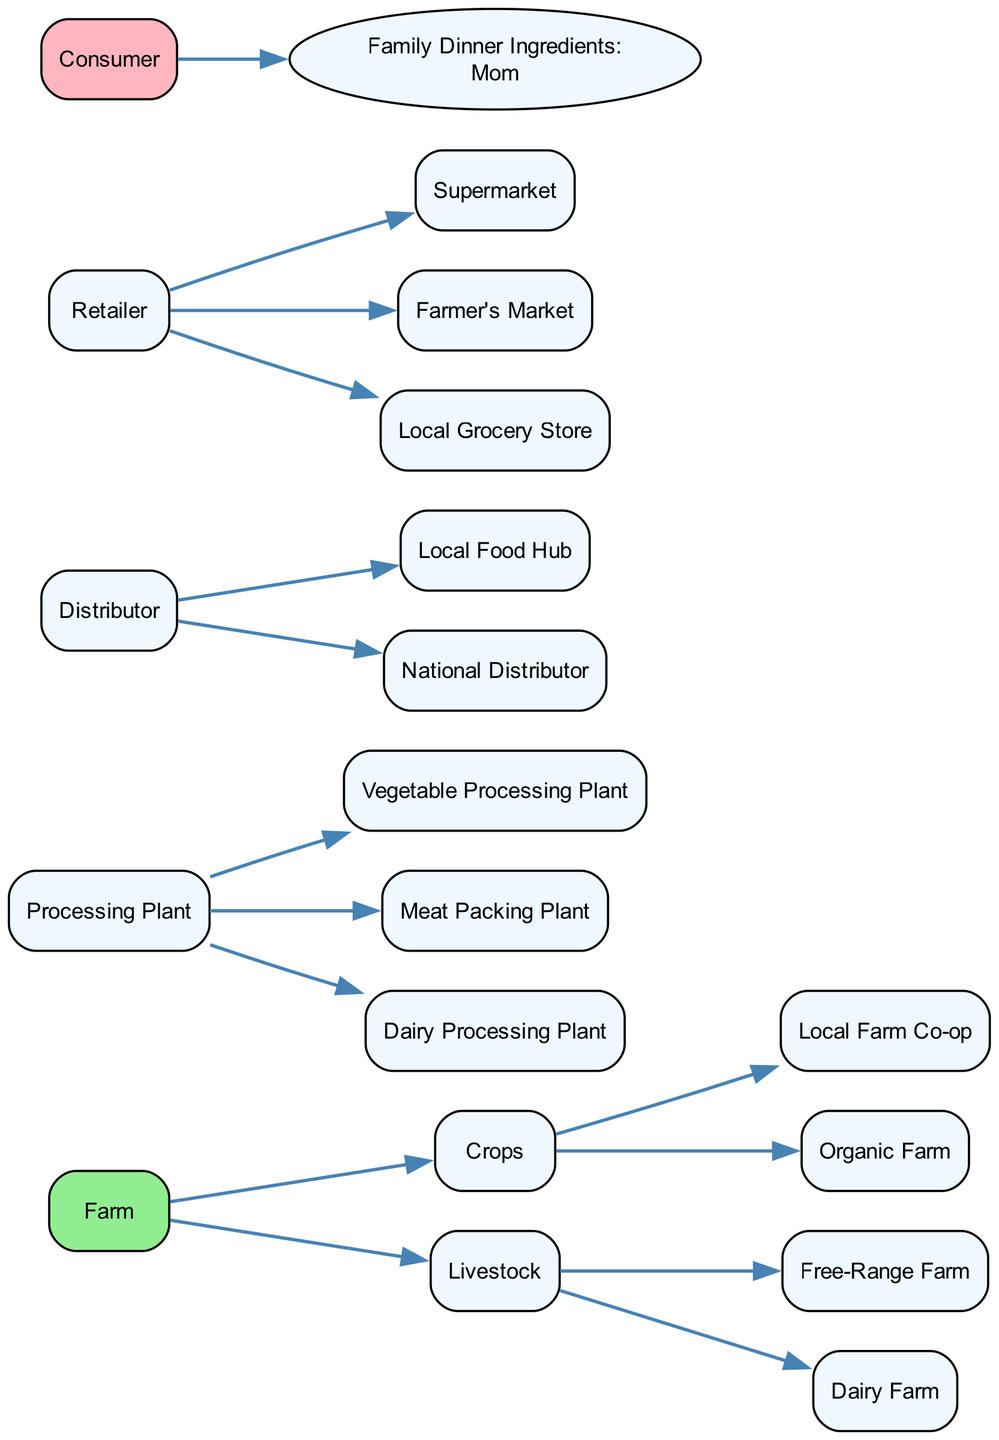What is the first step in the food chain? The food chain starts at the "Farm" node, which represents where food ingredients are grown and raised.
Answer: Farm How many types of livestock are represented? There are two types of livestock represented: "Free-Range Farm" and "Dairy Farm."
Answer: 2 Which plant processes vegetables? The "Vegetable Processing" node indicates the plant responsible for processing vegetables.
Answer: Vegetable Processing Plant What do consumers receive as the final product? The consumer receives "Family Dinner Ingredients" as the final product from the entire supply chain.
Answer: Family Dinner Ingredients: Mom Which retailer option involves direct purchasing from producers? The "Farmer's Market" is the retailer option where consumers can purchase directly from producers.
Answer: Farmer's Market Which distributor serves food locally? The "Local Food Hub" serves as the distributor for local food options.
Answer: Local Food Hub How many processing plants are listed in the diagram? There are three processing plants listed: "Vegetable Processing," "Meat Packing," and "Dairy Processing."
Answer: 3 What type of farm focuses on organic methods? The "Organic Farm" is specifically designated for organic farming practices.
Answer: Organic Farm Which category includes crops? The category that includes crops is labeled as "Crops" and has its own specific node.
Answer: Crops 